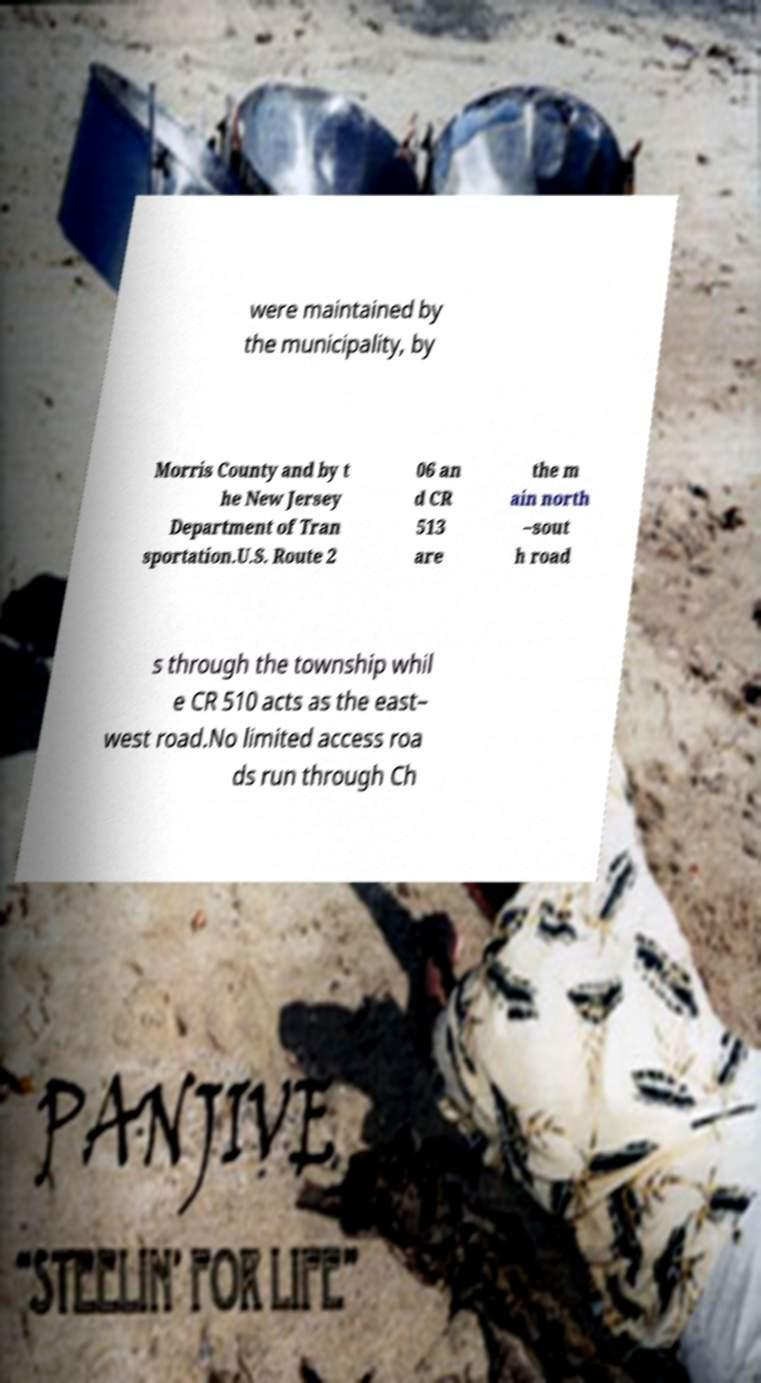What messages or text are displayed in this image? I need them in a readable, typed format. were maintained by the municipality, by Morris County and by t he New Jersey Department of Tran sportation.U.S. Route 2 06 an d CR 513 are the m ain north –sout h road s through the township whil e CR 510 acts as the east– west road.No limited access roa ds run through Ch 